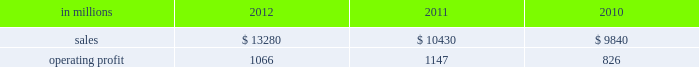( $ 125 million ) and higher maintenance outage costs ( $ 18 million ) .
Additionally , operating profits in 2012 include costs of $ 184 million associated with the acquisition and integration of temple-inland , mill divestiture costs of $ 91 million , costs associated with the restructuring of our european packaging busi- ness of $ 17 million and a $ 3 million gain for other items , while operating costs in 2011 included costs associated with signing an agreement to acquire temple-inland of $ 20 million and a gain of $ 7 million for other items .
Industrial packaging .
North american industr ia l packaging net sales were $ 11.6 billion in 2012 compared with $ 8.6 billion in 2011 and $ 8.4 billion in 2010 .
Operating profits in 2012 were $ 1.0 billion ( $ 1.3 billion exclud- ing costs associated with the acquisition and integration of temple-inland and mill divestiture costs ) compared with $ 1.1 billion ( both including and excluding costs associated with signing an agree- ment to acquire temple-inland ) in 2011 and $ 763 million ( $ 776 million excluding facility closure costs ) in 2010 .
Sales volumes for the legacy business were about flat in 2012 compared with 2011 .
Average sales price was lower mainly due to export containerboard sales prices which bottomed out in the first quarter but climbed steadily the rest of the year .
Input costs were lower for recycled fiber , wood and natural gas , but higher for starch .
Freight costs also increased .
Plan- ned maintenance downtime costs were higher than in 2011 .
Operating costs were higher largely due to routine inventory valuation adjustments operating profits in 2012 benefited from $ 235 million of temple-inland synergies .
Market-related downtime in 2012 was about 570000 tons compared with about 380000 tons in 2011 .
Operating profits in 2012 included $ 184 million of costs associated with the acquisition and integration of temple-inland and $ 91 million of costs associated with the divestiture of three containerboard mills .
Operating profits in 2011 included charges of $ 20 million for costs associated with the signing of the agreement to acquire temple- inland .
Looking ahead to 2013 , sales volumes in the first quarter compared with the fourth quarter of 2012 are expected to increase slightly for boxes due to a higher number of shipping days .
Average sales price realizations are expected to reflect the pass-through to box customers of a containerboard price increase implemented in 2012 .
Input costs are expected to be higher for recycled fiber , wood and starch .
Planned maintenance downtime costs are expected to be about $ 26 million higher with outages scheduled at eight mills compared with six mills in the 2012 fourth quarter .
Manufacturing operating costs are expected to be lower .
European industr ia l packaging net sales were $ 1.0 billion in 2012 compared with $ 1.1 billion in 2011 and $ 990 million in 2010 .
Operating profits in 2012 were $ 53 million ( $ 72 million excluding restructuring costs ) compared with $ 66 million ( $ 61 million excluding a gain for a bargain purchase price adjustment on an acquisition by our joint venture in turkey and costs associated with the closure of our etienne mill in france in 2009 ) in 2011 and $ 70 mil- lion ( $ 73 million before closure costs for our etienne mill ) in 2010 .
Sales volumes in 2012 were lower than in 2011 reflecting decreased demand for packaging in the industrial market due to a weaker overall economic environment in southern europe .
Demand for pack- aging in the agricultural markets was about flat year- over-year .
Average sales margins increased due to sales price increases implemented during 2011 and 2012 and lower board costs .
Other input costs were higher , primarily for energy and distribution .
Operat- ing profits in 2012 included a net gain of $ 10 million for an insurance settlement , partially offset by addi- tional operating costs , related to the earthquakes in northern italy in may which affected our san felice box plant .
Entering the first quarter of 2013 , sales volumes are expected to be stable reflecting a seasonal decrease in market demand in agricultural markets offset by an increase in industrial markets .
Average sales margins are expected to improve due to lower input costs for containerboard .
Other input costs should be about flat .
Operating costs are expected to be higher reflecting the absence of the earthquake insurance settlement that was received in the 2012 fourth quar- asian industr ia l packaging net sales and operating profits include the results of sca pack- aging since the acquisition on june 30 , 2010 , includ- ing the impact of incremental integration costs .
Net sales for the packaging operations were $ 400 million in 2012 compared with $ 410 million in 2011 and $ 255 million in 2010 .
Operating profits for the packaging operations were $ 2 million in 2012 compared with $ 2 million in 2011 and a loss of $ 7 million ( a loss of $ 4 million excluding facility closure costs ) in 2010 .
Operating profits were favorably impacted by higher average sales margins in 2012 compared with 2011 , but this benefit was offset by lower sales volumes and higher raw material costs and operating costs .
Looking ahead to the first quarter of 2013 , sales volumes and average sales margins are expected to decrease due to seasonality .
Net sales for the distribution operations were $ 260 million in 2012 compared with $ 285 million in 2011 and $ 240 million in 2010 .
Operating profits were $ 3 million in 2012 compared with $ 3 million in 2011 and about breakeven in 2010. .
North american industrial packaging net sales where what percent of industrial packaging sales in 2011? 
Computations: ((8.6 * 1000) / 10430)
Answer: 0.82454. 